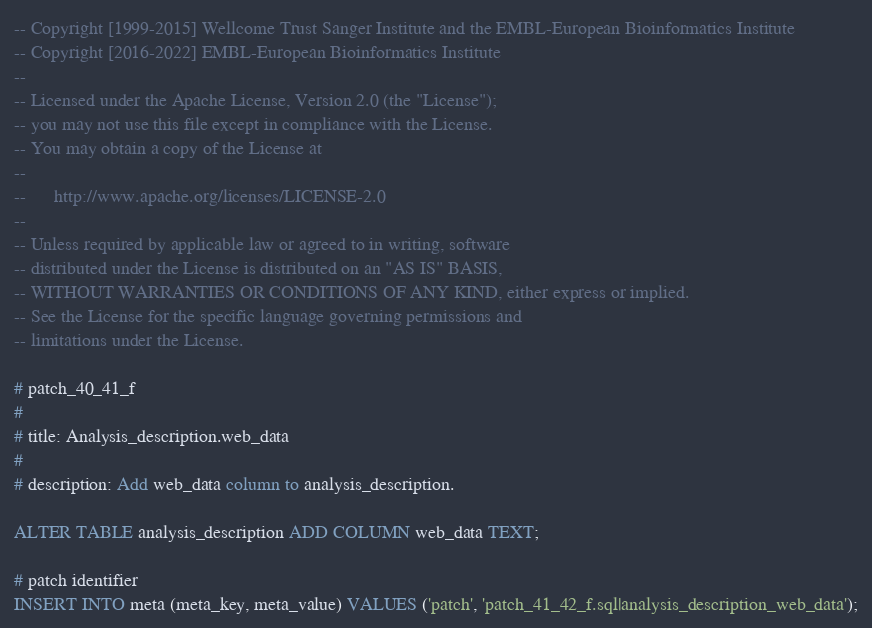<code> <loc_0><loc_0><loc_500><loc_500><_SQL_>-- Copyright [1999-2015] Wellcome Trust Sanger Institute and the EMBL-European Bioinformatics Institute
-- Copyright [2016-2022] EMBL-European Bioinformatics Institute
-- 
-- Licensed under the Apache License, Version 2.0 (the "License");
-- you may not use this file except in compliance with the License.
-- You may obtain a copy of the License at
-- 
--      http://www.apache.org/licenses/LICENSE-2.0
-- 
-- Unless required by applicable law or agreed to in writing, software
-- distributed under the License is distributed on an "AS IS" BASIS,
-- WITHOUT WARRANTIES OR CONDITIONS OF ANY KIND, either express or implied.
-- See the License for the specific language governing permissions and
-- limitations under the License.

# patch_40_41_f
#
# title: Analysis_description.web_data
#
# description: Add web_data column to analysis_description.

ALTER TABLE analysis_description ADD COLUMN web_data TEXT;

# patch identifier
INSERT INTO meta (meta_key, meta_value) VALUES ('patch', 'patch_41_42_f.sql|analysis_description_web_data');
</code> 